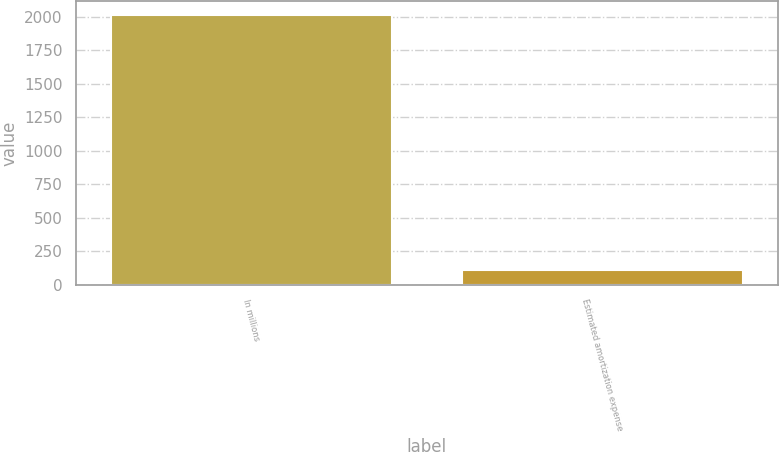<chart> <loc_0><loc_0><loc_500><loc_500><bar_chart><fcel>In millions<fcel>Estimated amortization expense<nl><fcel>2017<fcel>109<nl></chart> 